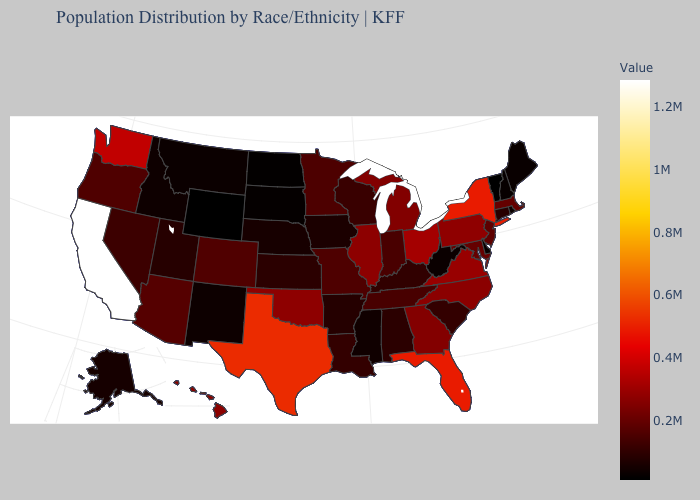Does the map have missing data?
Short answer required. No. Among the states that border New Jersey , does Pennsylvania have the lowest value?
Short answer required. No. Among the states that border Missouri , does Nebraska have the highest value?
Quick response, please. No. Does Ohio have the highest value in the MidWest?
Be succinct. Yes. Which states have the highest value in the USA?
Keep it brief. California. 